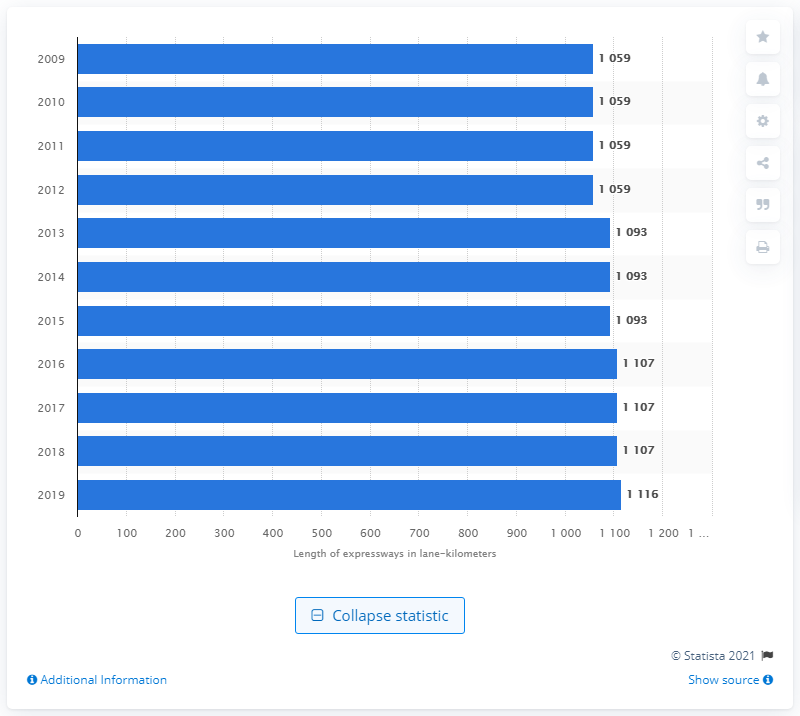Highlight a few significant elements in this photo. In 2019, a total of 1,093 lane-kilometers of roads in Singapore were paved as expressways. 